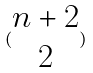<formula> <loc_0><loc_0><loc_500><loc_500>( \begin{matrix} n + 2 \\ 2 \end{matrix} )</formula> 